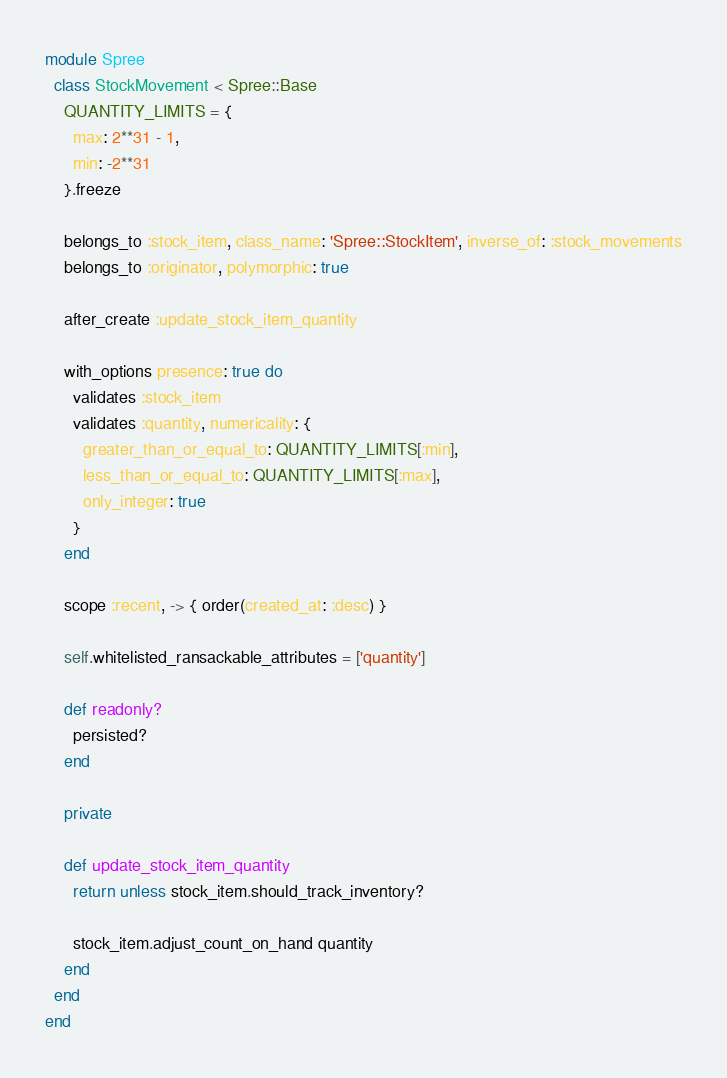Convert code to text. <code><loc_0><loc_0><loc_500><loc_500><_Ruby_>module Spree
  class StockMovement < Spree::Base
    QUANTITY_LIMITS = {
      max: 2**31 - 1,
      min: -2**31
    }.freeze

    belongs_to :stock_item, class_name: 'Spree::StockItem', inverse_of: :stock_movements
    belongs_to :originator, polymorphic: true

    after_create :update_stock_item_quantity

    with_options presence: true do
      validates :stock_item
      validates :quantity, numericality: {
        greater_than_or_equal_to: QUANTITY_LIMITS[:min],
        less_than_or_equal_to: QUANTITY_LIMITS[:max],
        only_integer: true
      }
    end

    scope :recent, -> { order(created_at: :desc) }

    self.whitelisted_ransackable_attributes = ['quantity']

    def readonly?
      persisted?
    end

    private

    def update_stock_item_quantity
      return unless stock_item.should_track_inventory?

      stock_item.adjust_count_on_hand quantity
    end
  end
end
</code> 